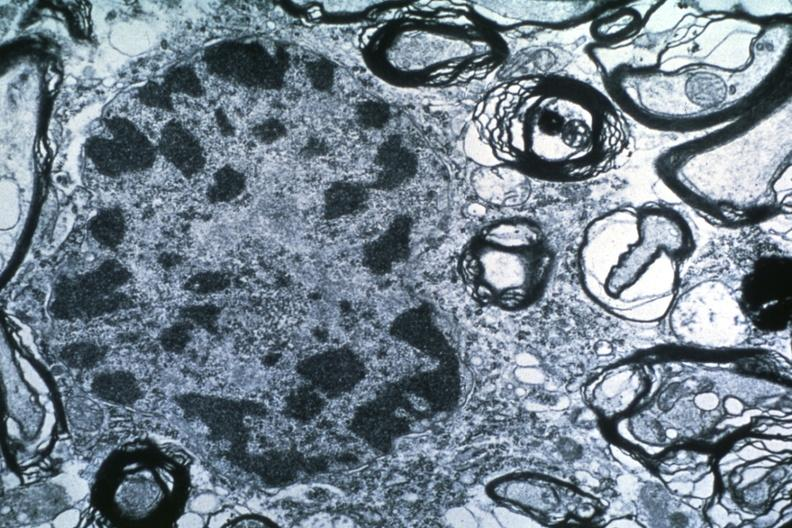what does this image show?
Answer the question using a single word or phrase. Dr garcia tumors 51 